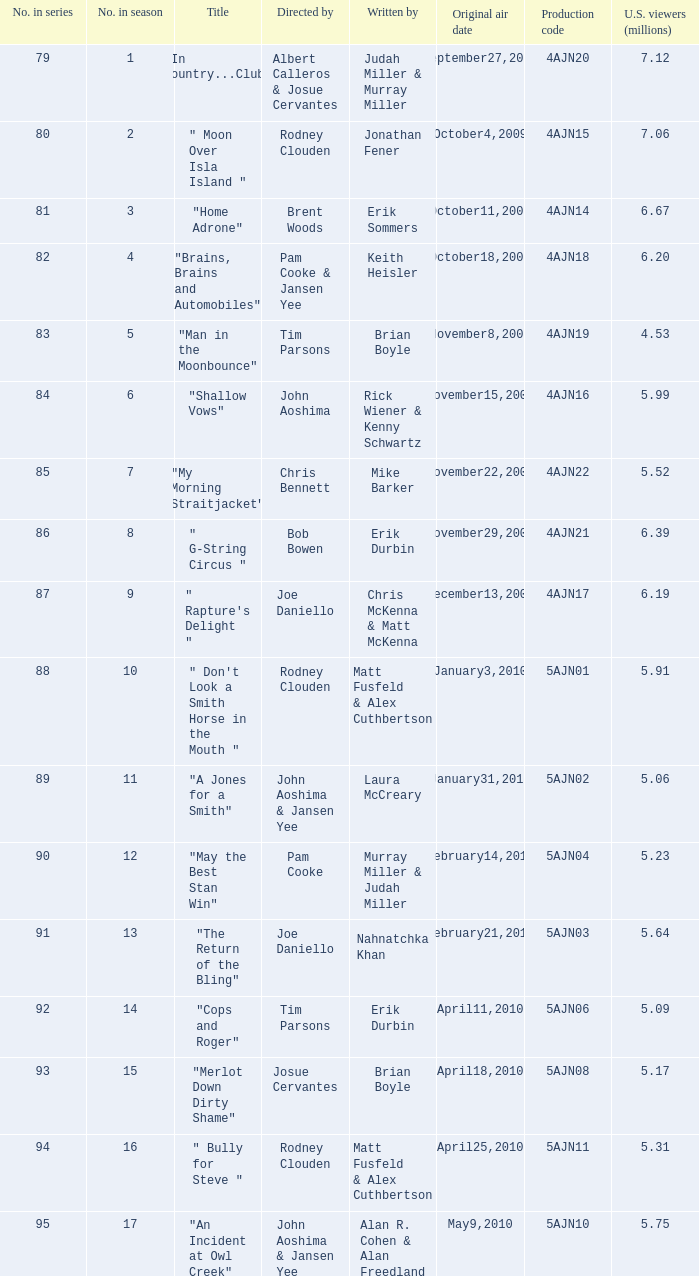State the person who penned the episode directed by pam cooke & jansen yee. Keith Heisler. 